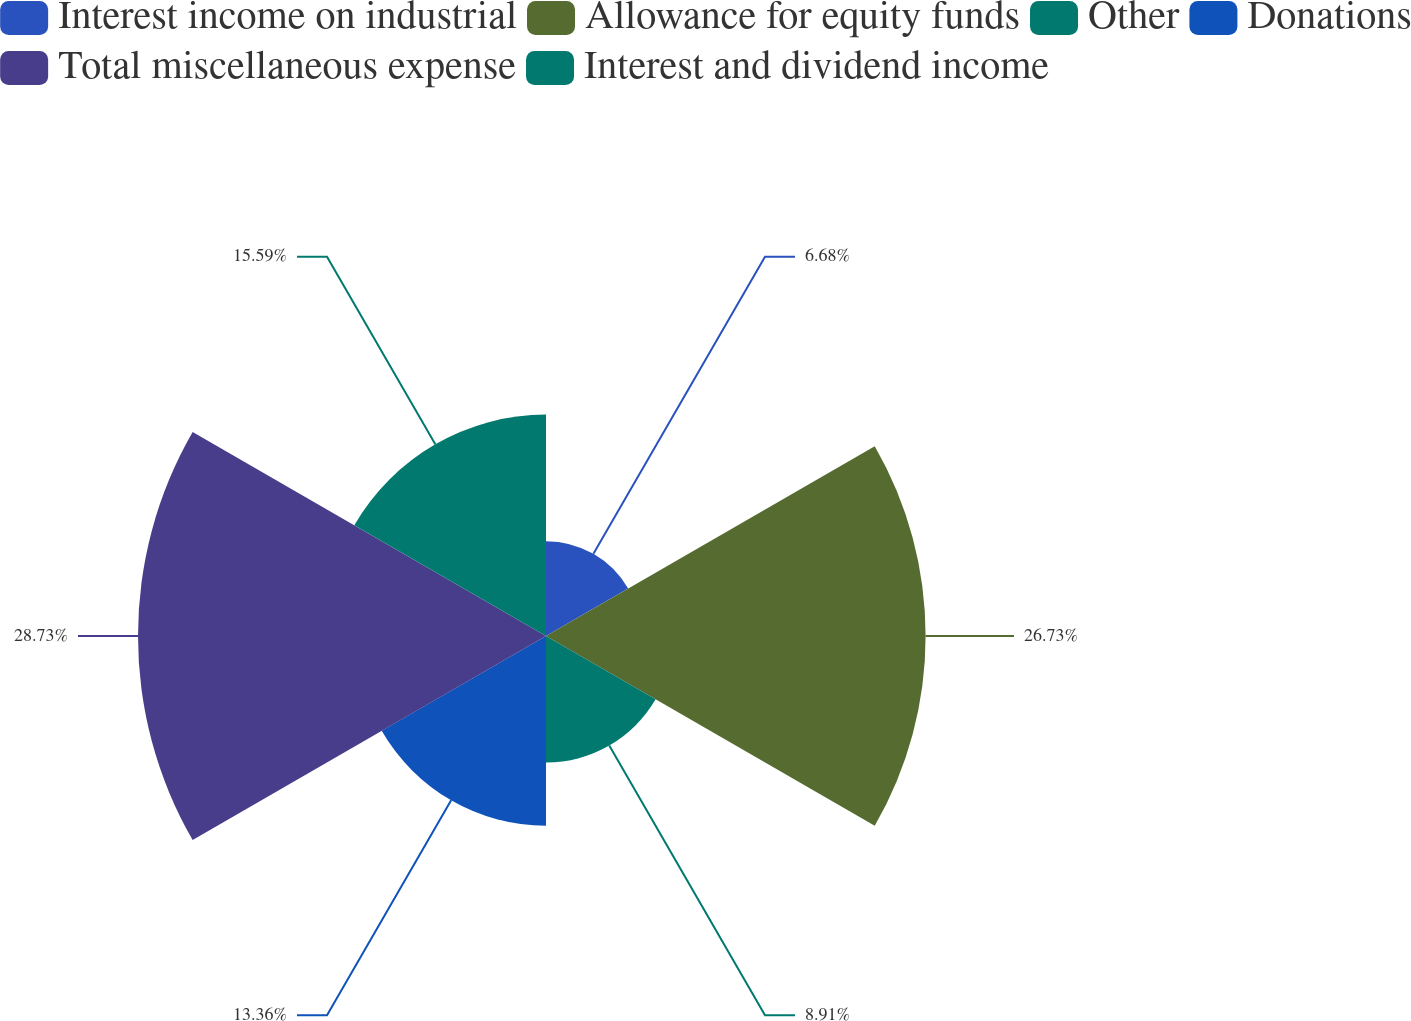Convert chart. <chart><loc_0><loc_0><loc_500><loc_500><pie_chart><fcel>Interest income on industrial<fcel>Allowance for equity funds<fcel>Other<fcel>Donations<fcel>Total miscellaneous expense<fcel>Interest and dividend income<nl><fcel>6.68%<fcel>26.73%<fcel>8.91%<fcel>13.36%<fcel>28.73%<fcel>15.59%<nl></chart> 